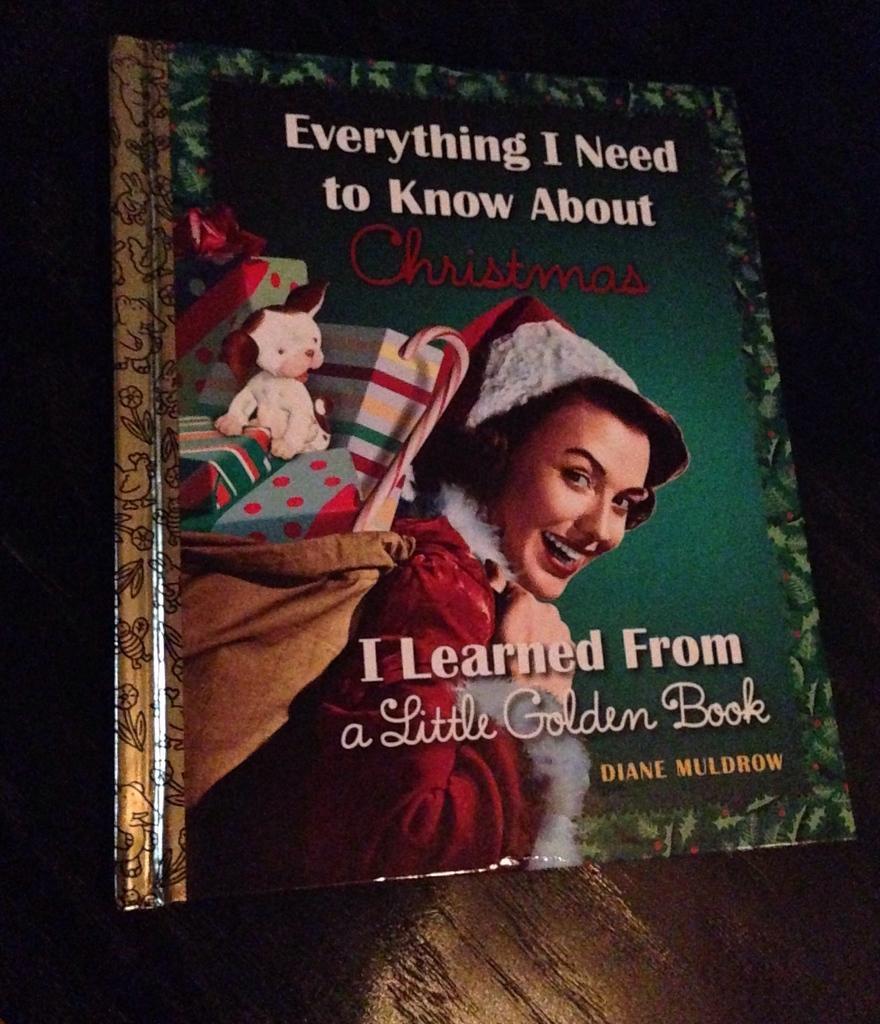In one or two sentences, can you explain what this image depicts? In the center of the image we can see one book. On the book, we can see one woman wearing some objects and she is in red and white color costume. And she is smiling, which we can see on her face. In the background we can see a few other objects. 